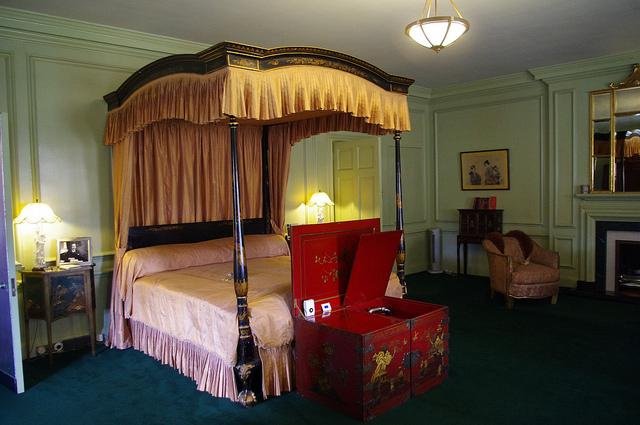Is this indoors?
Keep it brief. Yes. What kind of bed is in the picture?
Give a very brief answer. Canopy. How many beds are there?
Give a very brief answer. 1. Is the floor wood?
Give a very brief answer. No. Is there a fire in the fireplace?
Quick response, please. No. 